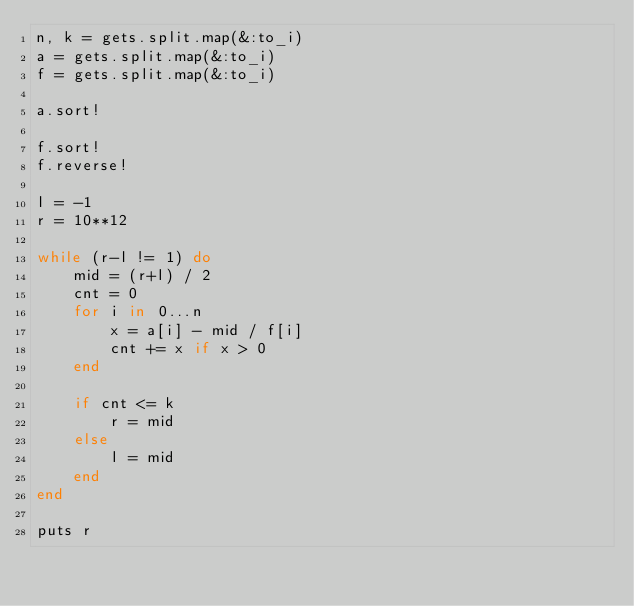Convert code to text. <code><loc_0><loc_0><loc_500><loc_500><_Ruby_>n, k = gets.split.map(&:to_i)
a = gets.split.map(&:to_i)
f = gets.split.map(&:to_i)

a.sort!

f.sort!
f.reverse!

l = -1
r = 10**12

while (r-l != 1) do
    mid = (r+l) / 2
    cnt = 0
    for i in 0...n
        x = a[i] - mid / f[i]
        cnt += x if x > 0
    end

    if cnt <= k
        r = mid
    else
        l = mid
    end
end

puts r
</code> 